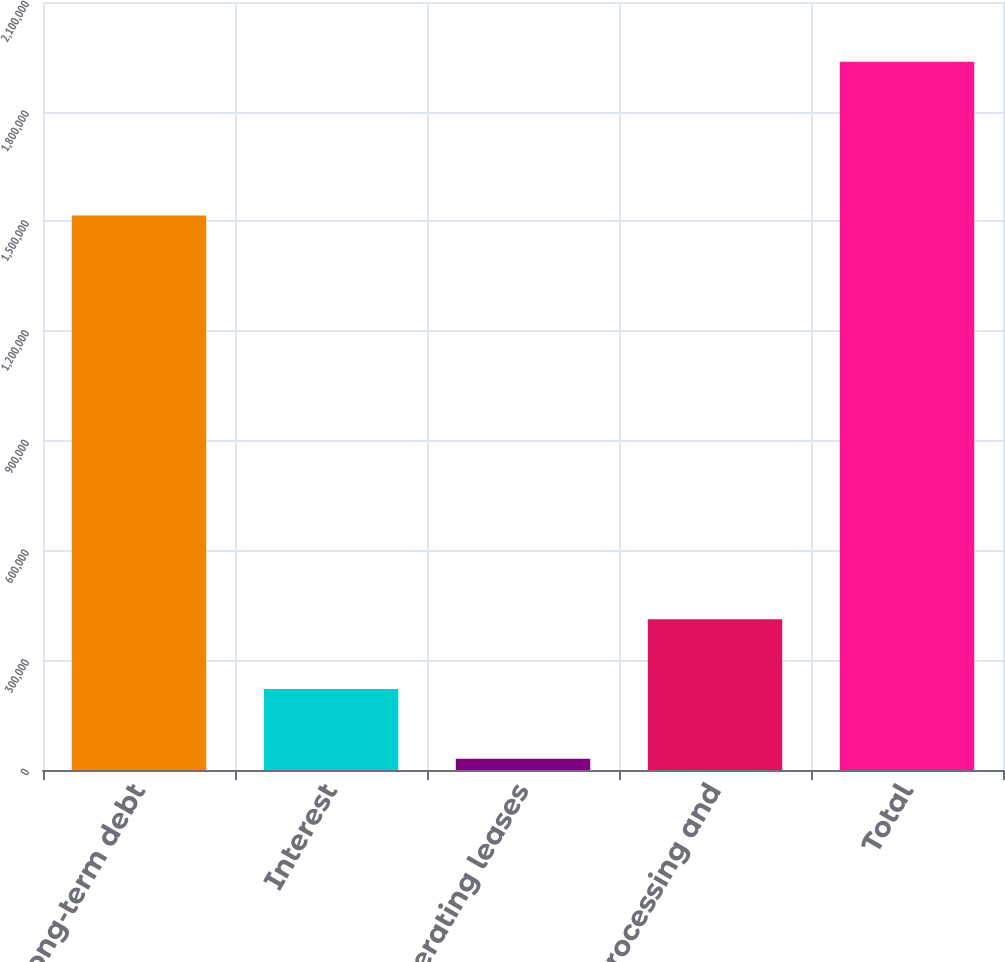Convert chart. <chart><loc_0><loc_0><loc_500><loc_500><bar_chart><fcel>Long-term debt<fcel>Interest<fcel>Operating leases<fcel>Data processing and<fcel>Total<nl><fcel>1.516e+06<fcel>221416<fcel>30869<fcel>411962<fcel>1.93634e+06<nl></chart> 